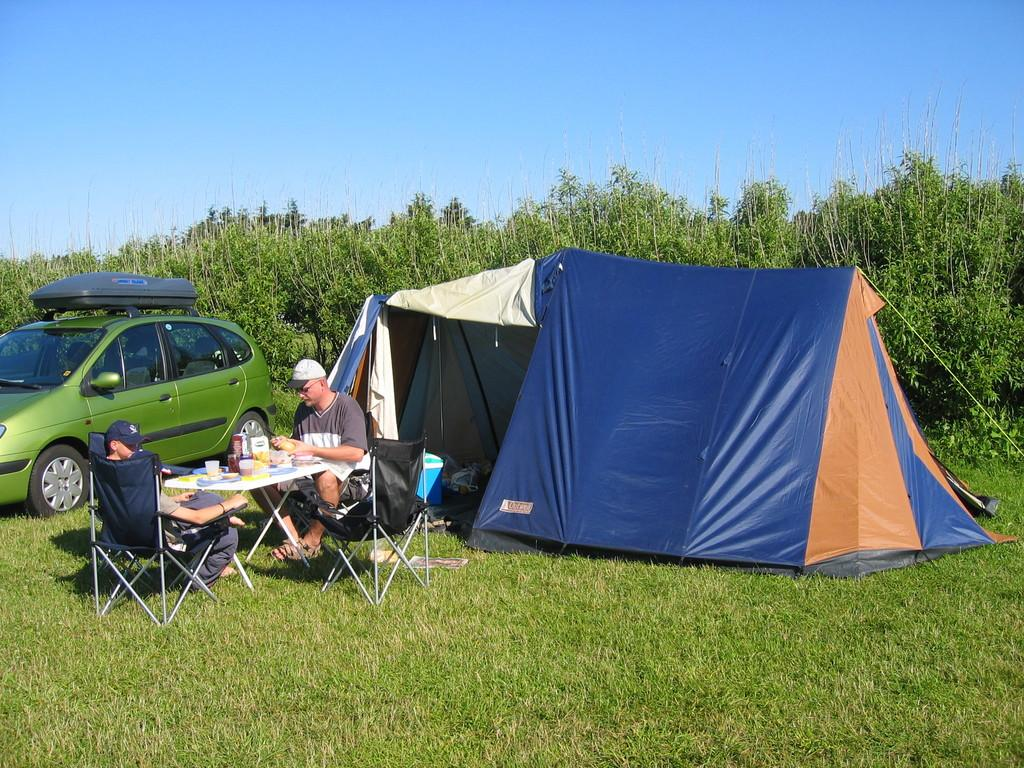How many people are sitting on the chair in the image? There are two people sitting on a chair in the image. What is parked nearby the people? There is a car parked nearby in the image. What type of shelter is present in the scene? There is a tent in the scene. What can be seen in the background of the image? Trees and a clear sky are visible in the background of the image. How many planes are flying over the tent in the image? There are no planes visible in the image; it only shows two people sitting on a chair, a car, a tent, trees, and a clear sky in the background. 